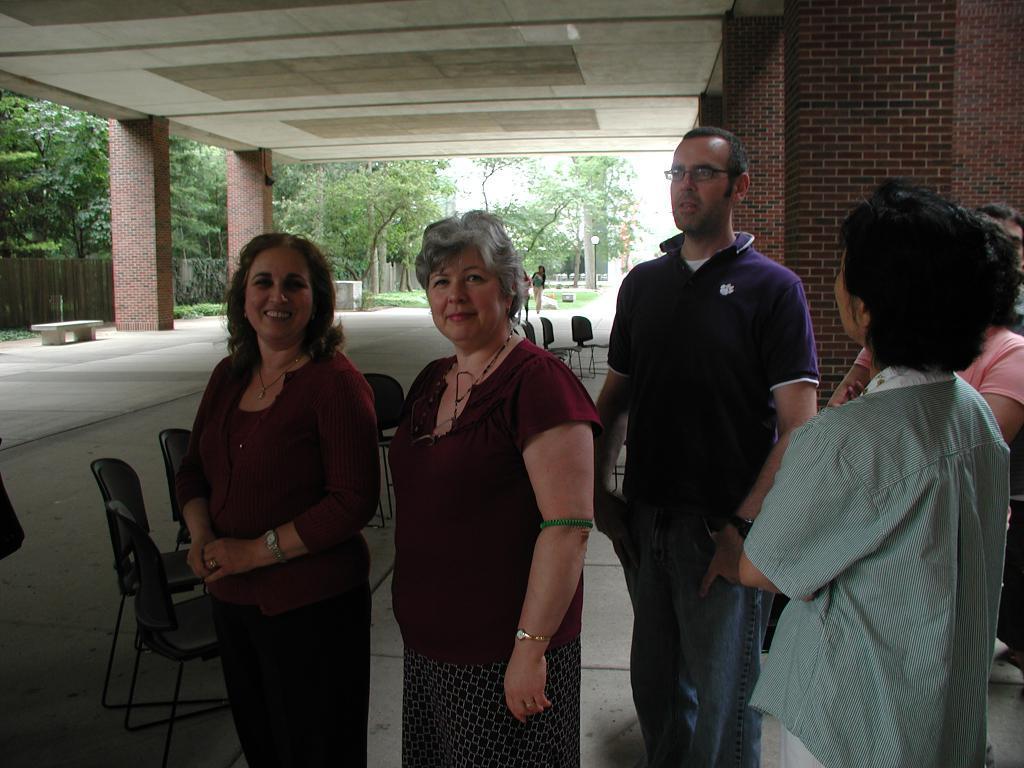Please provide a concise description of this image. In this image I can see few people are standing. I can also see smile on few faces. Here I can see he is wearing a specs. In the background I can see number of trees and few more people. 